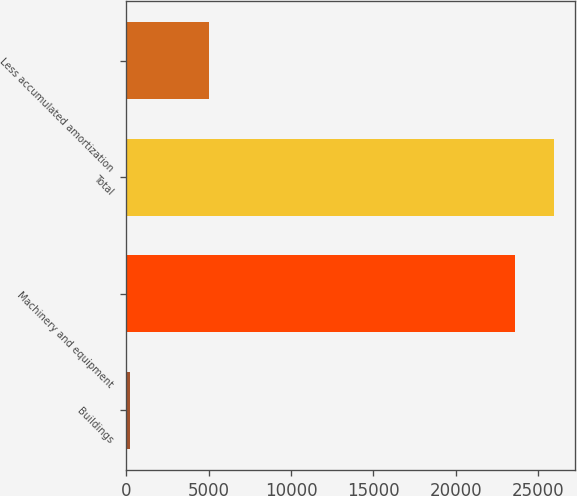Convert chart to OTSL. <chart><loc_0><loc_0><loc_500><loc_500><bar_chart><fcel>Buildings<fcel>Machinery and equipment<fcel>Total<fcel>Less accumulated amortization<nl><fcel>250<fcel>23602<fcel>25962.2<fcel>5028<nl></chart> 